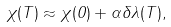<formula> <loc_0><loc_0><loc_500><loc_500>\chi ( T ) \approx \chi ( 0 ) + \alpha \delta \lambda ( T ) ,</formula> 